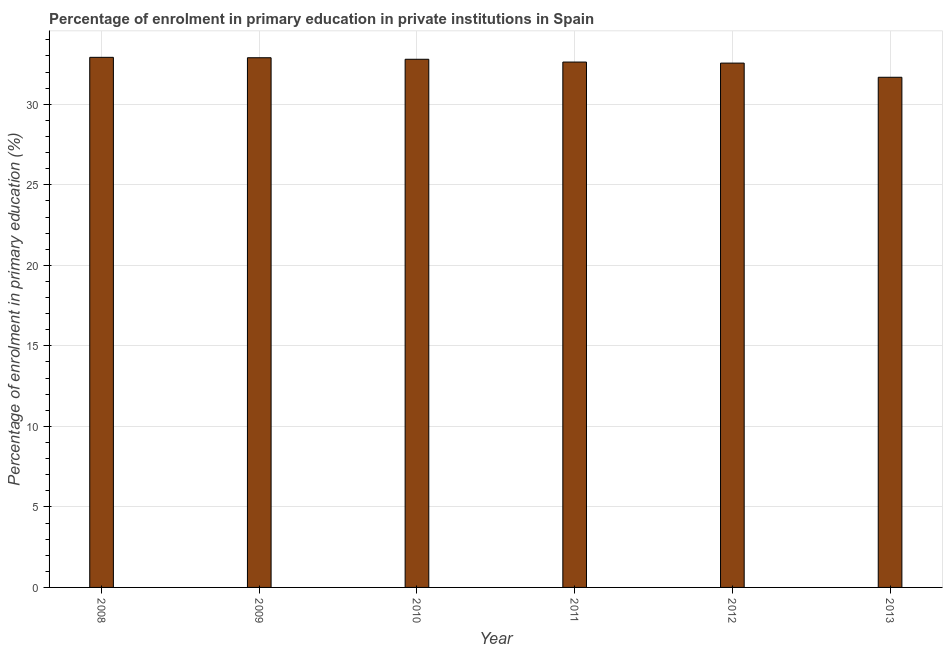Does the graph contain any zero values?
Your answer should be compact. No. What is the title of the graph?
Give a very brief answer. Percentage of enrolment in primary education in private institutions in Spain. What is the label or title of the Y-axis?
Offer a terse response. Percentage of enrolment in primary education (%). What is the enrolment percentage in primary education in 2008?
Offer a very short reply. 32.92. Across all years, what is the maximum enrolment percentage in primary education?
Provide a succinct answer. 32.92. Across all years, what is the minimum enrolment percentage in primary education?
Offer a very short reply. 31.68. What is the sum of the enrolment percentage in primary education?
Offer a very short reply. 195.46. What is the difference between the enrolment percentage in primary education in 2008 and 2012?
Ensure brevity in your answer.  0.36. What is the average enrolment percentage in primary education per year?
Give a very brief answer. 32.58. What is the median enrolment percentage in primary education?
Provide a succinct answer. 32.71. What is the ratio of the enrolment percentage in primary education in 2008 to that in 2013?
Give a very brief answer. 1.04. Is the enrolment percentage in primary education in 2011 less than that in 2012?
Offer a terse response. No. What is the difference between the highest and the second highest enrolment percentage in primary education?
Ensure brevity in your answer.  0.03. Is the sum of the enrolment percentage in primary education in 2009 and 2010 greater than the maximum enrolment percentage in primary education across all years?
Your answer should be very brief. Yes. What is the difference between the highest and the lowest enrolment percentage in primary education?
Make the answer very short. 1.24. Are the values on the major ticks of Y-axis written in scientific E-notation?
Your answer should be very brief. No. What is the Percentage of enrolment in primary education (%) in 2008?
Offer a very short reply. 32.92. What is the Percentage of enrolment in primary education (%) in 2009?
Make the answer very short. 32.89. What is the Percentage of enrolment in primary education (%) in 2010?
Your answer should be very brief. 32.8. What is the Percentage of enrolment in primary education (%) of 2011?
Provide a succinct answer. 32.62. What is the Percentage of enrolment in primary education (%) of 2012?
Your response must be concise. 32.56. What is the Percentage of enrolment in primary education (%) of 2013?
Provide a short and direct response. 31.68. What is the difference between the Percentage of enrolment in primary education (%) in 2008 and 2009?
Provide a short and direct response. 0.03. What is the difference between the Percentage of enrolment in primary education (%) in 2008 and 2010?
Your response must be concise. 0.12. What is the difference between the Percentage of enrolment in primary education (%) in 2008 and 2011?
Your answer should be compact. 0.29. What is the difference between the Percentage of enrolment in primary education (%) in 2008 and 2012?
Your response must be concise. 0.36. What is the difference between the Percentage of enrolment in primary education (%) in 2008 and 2013?
Your response must be concise. 1.24. What is the difference between the Percentage of enrolment in primary education (%) in 2009 and 2010?
Provide a short and direct response. 0.1. What is the difference between the Percentage of enrolment in primary education (%) in 2009 and 2011?
Your answer should be compact. 0.27. What is the difference between the Percentage of enrolment in primary education (%) in 2009 and 2012?
Your response must be concise. 0.33. What is the difference between the Percentage of enrolment in primary education (%) in 2009 and 2013?
Offer a very short reply. 1.21. What is the difference between the Percentage of enrolment in primary education (%) in 2010 and 2011?
Provide a short and direct response. 0.17. What is the difference between the Percentage of enrolment in primary education (%) in 2010 and 2012?
Your answer should be compact. 0.24. What is the difference between the Percentage of enrolment in primary education (%) in 2010 and 2013?
Your answer should be compact. 1.12. What is the difference between the Percentage of enrolment in primary education (%) in 2011 and 2012?
Give a very brief answer. 0.06. What is the difference between the Percentage of enrolment in primary education (%) in 2011 and 2013?
Give a very brief answer. 0.94. What is the difference between the Percentage of enrolment in primary education (%) in 2012 and 2013?
Make the answer very short. 0.88. What is the ratio of the Percentage of enrolment in primary education (%) in 2008 to that in 2010?
Your answer should be very brief. 1. What is the ratio of the Percentage of enrolment in primary education (%) in 2008 to that in 2013?
Give a very brief answer. 1.04. What is the ratio of the Percentage of enrolment in primary education (%) in 2009 to that in 2012?
Your response must be concise. 1.01. What is the ratio of the Percentage of enrolment in primary education (%) in 2009 to that in 2013?
Give a very brief answer. 1.04. What is the ratio of the Percentage of enrolment in primary education (%) in 2010 to that in 2012?
Provide a succinct answer. 1.01. What is the ratio of the Percentage of enrolment in primary education (%) in 2010 to that in 2013?
Your response must be concise. 1.03. What is the ratio of the Percentage of enrolment in primary education (%) in 2011 to that in 2012?
Your response must be concise. 1. What is the ratio of the Percentage of enrolment in primary education (%) in 2012 to that in 2013?
Offer a very short reply. 1.03. 